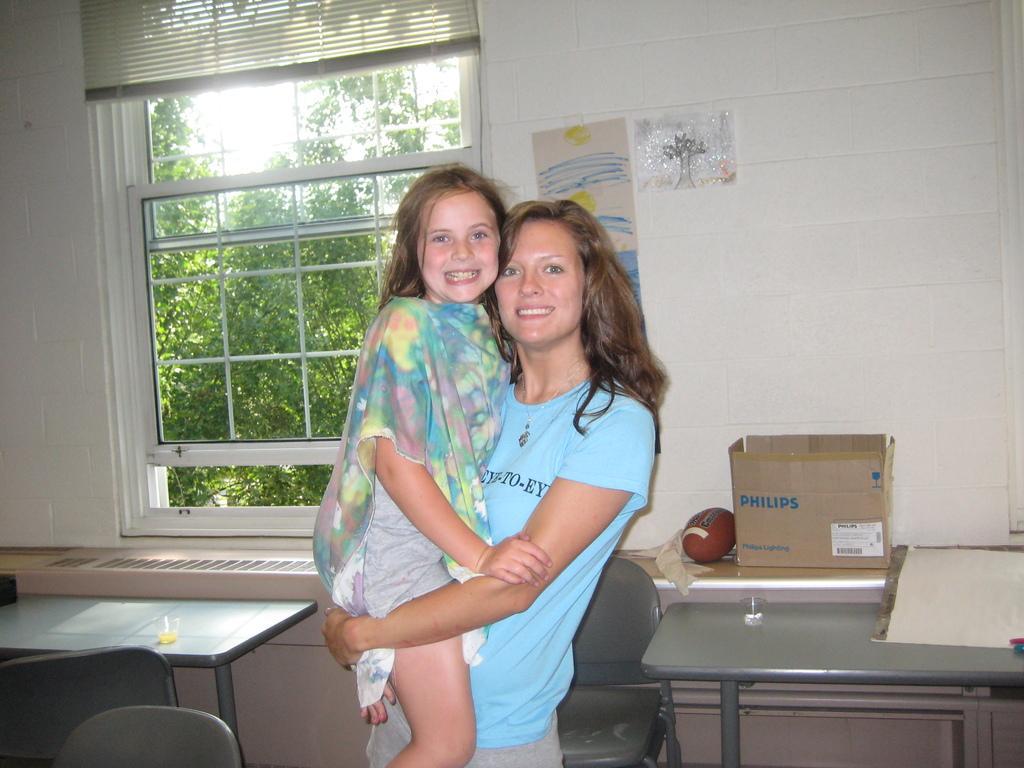Can you describe this image briefly? The women wearing blue dress is carrying a kid with her hands and there are tables,chairs and a window in the background. 